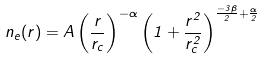Convert formula to latex. <formula><loc_0><loc_0><loc_500><loc_500>n _ { e } ( r ) = A \left ( \frac { r } { r _ { c } } \right ) ^ { - \alpha } \left ( 1 + \frac { r ^ { 2 } } { r _ { c } ^ { 2 } } \right ) ^ { \frac { - 3 \beta } { 2 } + \frac { \alpha } { 2 } }</formula> 